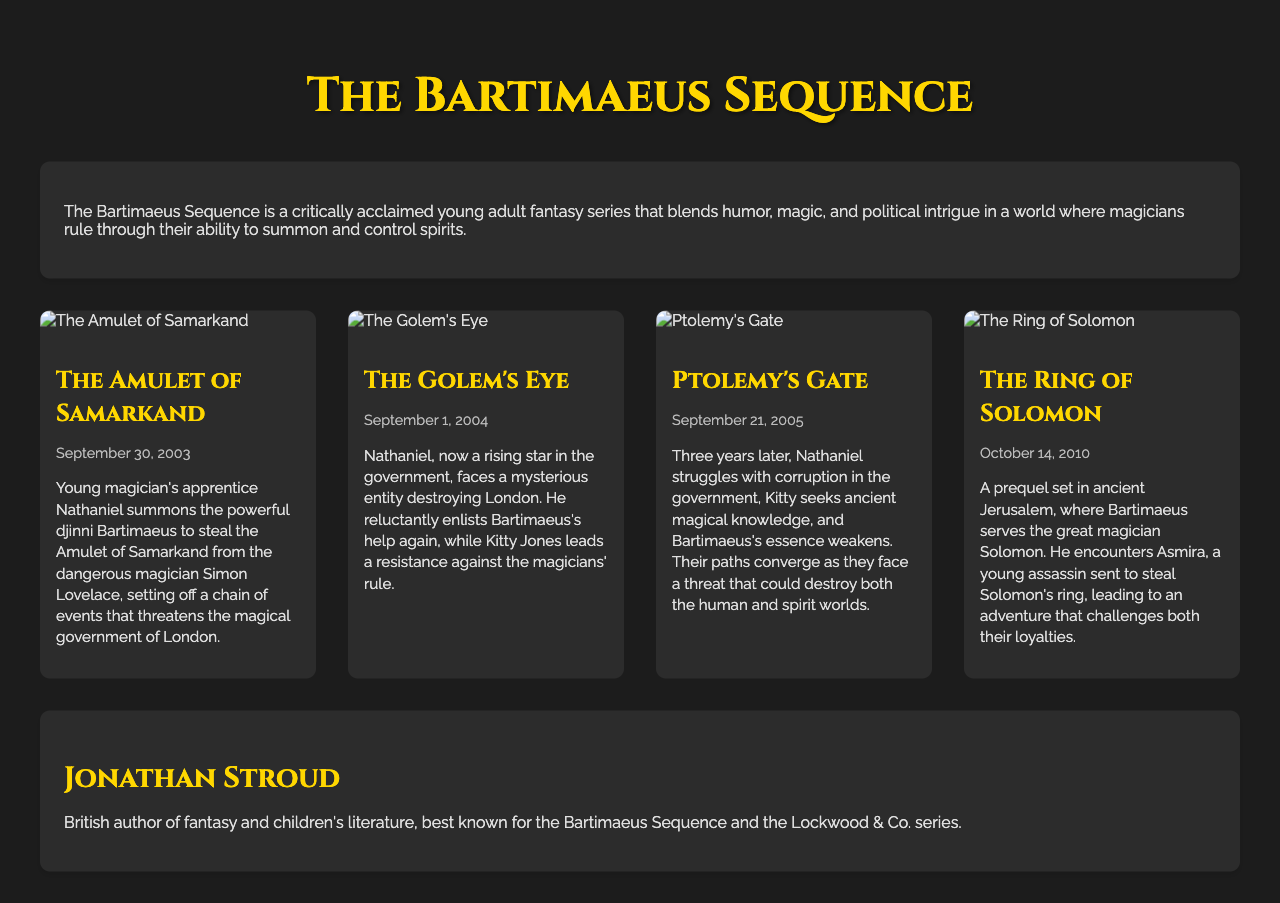What is the first book in the Bartimaeus Sequence? The document outlines the titles of each book, with "The Amulet of Samarkand" listed first.
Answer: The Amulet of Samarkand When was "The Golem's Eye" published? The publication date for "The Golem's Eye" is provided in the document under its title.
Answer: September 1, 2004 Who is the author of the Bartimaeus Sequence? The author’s name is mentioned in the author info section of the document.
Answer: Jonathan Stroud What is the setting of "The Ring of Solomon"? The synopsis for "The Ring of Solomon" specifies that it is set in ancient Jerusalem.
Answer: Ancient Jerusalem In which book does Kitty Jones lead a resistance? The document states that Kitty Jones leads a resistance in "The Golem's Eye".
Answer: The Golem's Eye How many books are listed in the catalog? The document lists a total of four books in the Bartimaeus Sequence.
Answer: Four What underlying theme is prevalent in the Bartimaeus Sequence? The series overview mentions themes such as humor, magic, and political intrigue.
Answer: Humor, magic, and political intrigue What magical artifact does Nathaniel seek in "The Amulet of Samarkand"? The synopsis of "The Amulet of Samarkand" indicates that Nathaniel seeks the Amulet of Samarkand.
Answer: Amulet of Samarkand Which book features Bartimaeus serving Solomon? The synopsis for "The Ring of Solomon" states that Bartimaeus serves Solomon, making it the relevant book.
Answer: The Ring of Solomon 